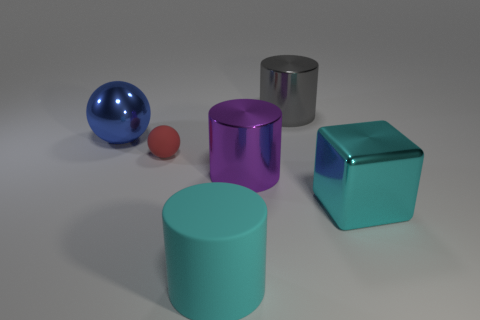What color is the metallic thing that is both to the left of the gray cylinder and in front of the large shiny ball?
Provide a succinct answer. Purple. Are there any other things that are the same size as the blue shiny thing?
Provide a short and direct response. Yes. There is a cylinder behind the large blue thing; is it the same color as the matte cylinder?
Provide a succinct answer. No. How many cubes are either rubber objects or large cyan rubber things?
Your answer should be compact. 0. What is the shape of the cyan thing in front of the big cyan shiny thing?
Offer a terse response. Cylinder. The big thing in front of the thing to the right of the shiny cylinder behind the tiny thing is what color?
Ensure brevity in your answer.  Cyan. Are the cyan block and the blue ball made of the same material?
Provide a short and direct response. Yes. What number of blue things are either blocks or cylinders?
Offer a terse response. 0. How many cyan rubber things are to the right of the rubber cylinder?
Provide a short and direct response. 0. Are there more green objects than gray metallic things?
Your answer should be very brief. No. 